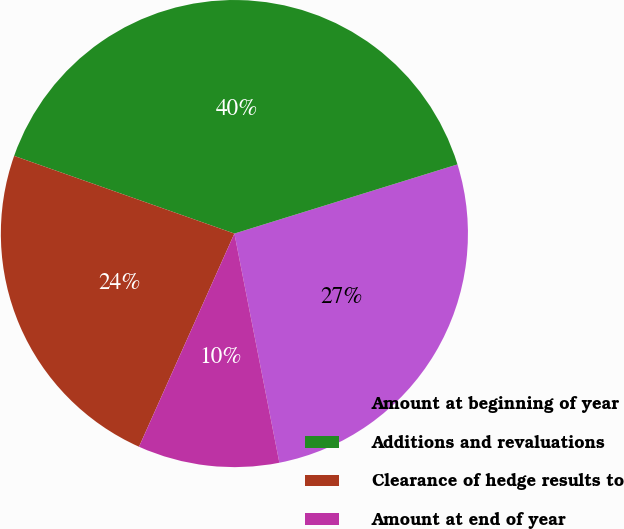Convert chart to OTSL. <chart><loc_0><loc_0><loc_500><loc_500><pie_chart><fcel>Amount at beginning of year<fcel>Additions and revaluations<fcel>Clearance of hedge results to<fcel>Amount at end of year<nl><fcel>26.7%<fcel>39.82%<fcel>23.7%<fcel>9.78%<nl></chart> 